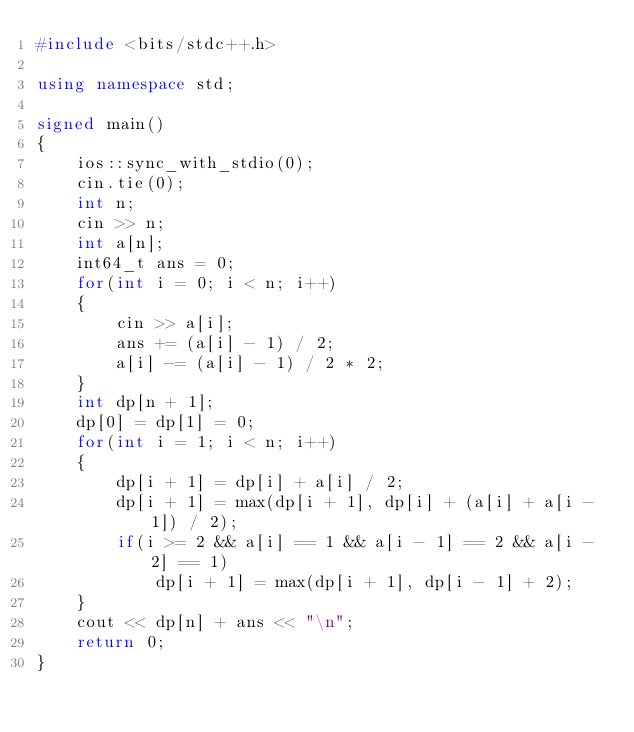Convert code to text. <code><loc_0><loc_0><loc_500><loc_500><_C++_>#include <bits/stdc++.h>

using namespace std;

signed main()
{
    ios::sync_with_stdio(0);
    cin.tie(0);
    int n;
    cin >> n;
    int a[n];
    int64_t ans = 0;
    for(int i = 0; i < n; i++)
    {
        cin >> a[i];
        ans += (a[i] - 1) / 2;
        a[i] -= (a[i] - 1) / 2 * 2;
    }
    int dp[n + 1];
    dp[0] = dp[1] = 0;
    for(int i = 1; i < n; i++)
    {
        dp[i + 1] = dp[i] + a[i] / 2;
        dp[i + 1] = max(dp[i + 1], dp[i] + (a[i] + a[i - 1]) / 2);
        if(i >= 2 && a[i] == 1 && a[i - 1] == 2 && a[i - 2] == 1)
            dp[i + 1] = max(dp[i + 1], dp[i - 1] + 2);
    }
    cout << dp[n] + ans << "\n";
    return 0;
}
</code> 